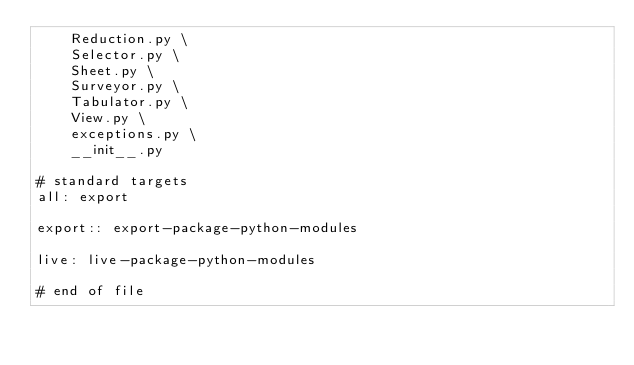<code> <loc_0><loc_0><loc_500><loc_500><_ObjectiveC_>    Reduction.py \
    Selector.py \
    Sheet.py \
    Surveyor.py \
    Tabulator.py \
    View.py \
    exceptions.py \
    __init__.py

# standard targets
all: export

export:: export-package-python-modules

live: live-package-python-modules

# end of file
</code> 